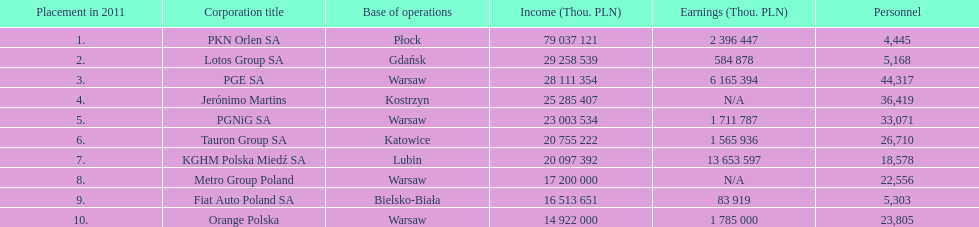Which company had the most employees? PGE SA. 